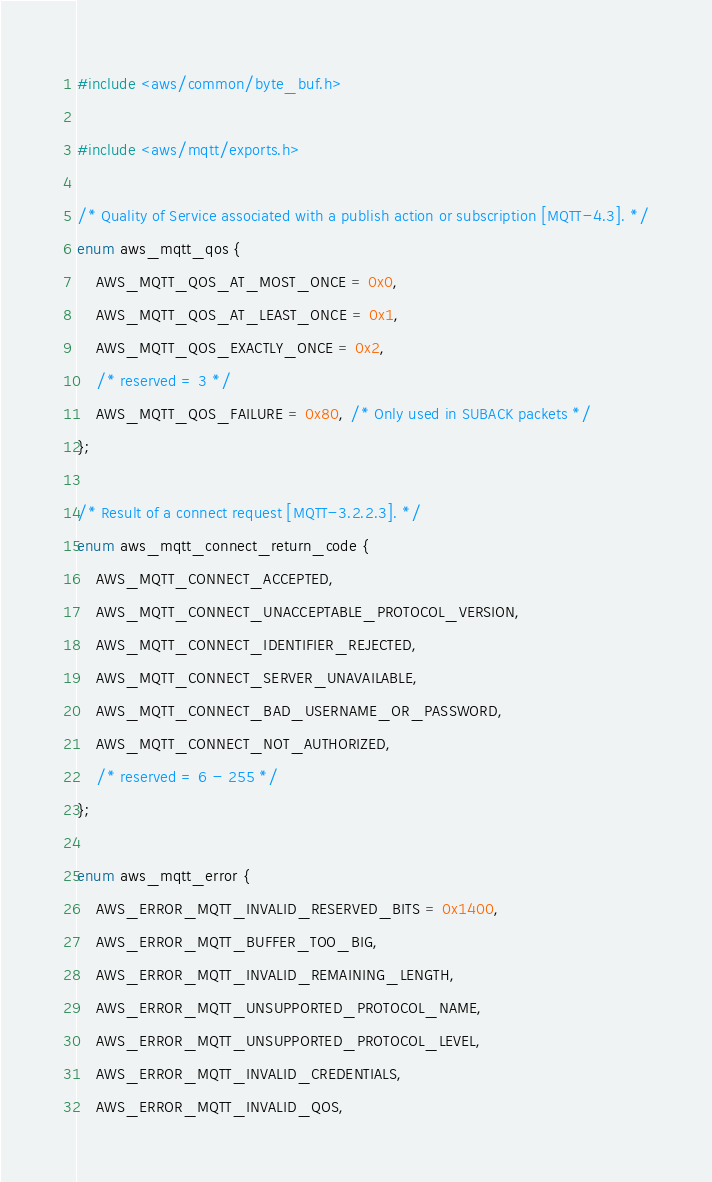Convert code to text. <code><loc_0><loc_0><loc_500><loc_500><_C_>#include <aws/common/byte_buf.h>

#include <aws/mqtt/exports.h>

/* Quality of Service associated with a publish action or subscription [MQTT-4.3]. */
enum aws_mqtt_qos {
    AWS_MQTT_QOS_AT_MOST_ONCE = 0x0,
    AWS_MQTT_QOS_AT_LEAST_ONCE = 0x1,
    AWS_MQTT_QOS_EXACTLY_ONCE = 0x2,
    /* reserved = 3 */
    AWS_MQTT_QOS_FAILURE = 0x80, /* Only used in SUBACK packets */
};

/* Result of a connect request [MQTT-3.2.2.3]. */
enum aws_mqtt_connect_return_code {
    AWS_MQTT_CONNECT_ACCEPTED,
    AWS_MQTT_CONNECT_UNACCEPTABLE_PROTOCOL_VERSION,
    AWS_MQTT_CONNECT_IDENTIFIER_REJECTED,
    AWS_MQTT_CONNECT_SERVER_UNAVAILABLE,
    AWS_MQTT_CONNECT_BAD_USERNAME_OR_PASSWORD,
    AWS_MQTT_CONNECT_NOT_AUTHORIZED,
    /* reserved = 6 - 255 */
};

enum aws_mqtt_error {
    AWS_ERROR_MQTT_INVALID_RESERVED_BITS = 0x1400,
    AWS_ERROR_MQTT_BUFFER_TOO_BIG,
    AWS_ERROR_MQTT_INVALID_REMAINING_LENGTH,
    AWS_ERROR_MQTT_UNSUPPORTED_PROTOCOL_NAME,
    AWS_ERROR_MQTT_UNSUPPORTED_PROTOCOL_LEVEL,
    AWS_ERROR_MQTT_INVALID_CREDENTIALS,
    AWS_ERROR_MQTT_INVALID_QOS,</code> 